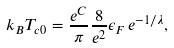Convert formula to latex. <formula><loc_0><loc_0><loc_500><loc_500>k _ { B } T _ { c 0 } = \frac { e ^ { C } } { \pi } \frac { 8 } { e ^ { 2 } } \epsilon _ { F } \, e ^ { - 1 / \lambda } ,</formula> 